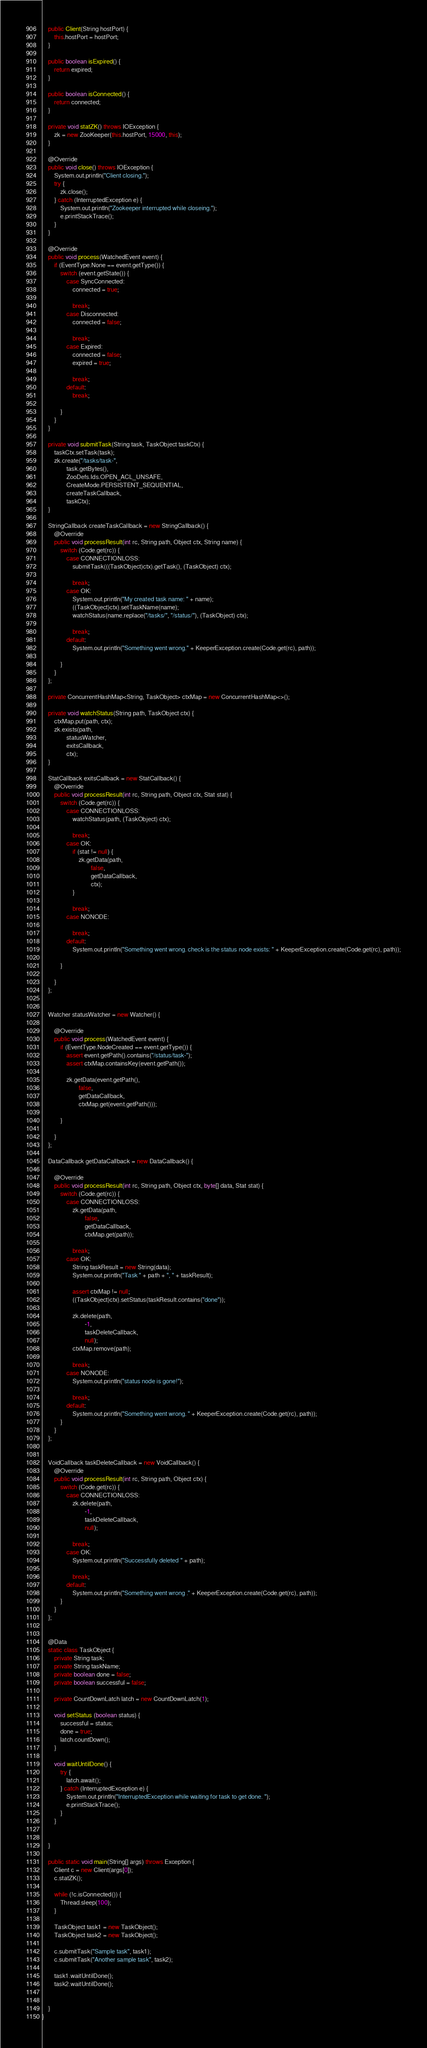Convert code to text. <code><loc_0><loc_0><loc_500><loc_500><_Java_>
	public Client(String hostPort) {
		this.hostPort = hostPort;
	}

	public boolean isExpired() {
		return expired;
	}

	public boolean isConnected() {
		return connected;
	}

	private void statZK() throws IOException {
		zk = new ZooKeeper(this.hostPort, 15000, this);
	}

	@Override
	public void close() throws IOException {
		System.out.println("Client closing.");
		try {
			zk.close();
		} catch (InterruptedException e) {
			System.out.println("Zookeeper interrupted while closeing.");
			e.printStackTrace();
		}
	}

	@Override
	public void process(WatchedEvent event) {
		if (EventType.None == event.getType()) {
			switch (event.getState()) {
				case SyncConnected:
					connected = true;

					break;
				case Disconnected:
					connected = false;

					break;
				case Expired:
					connected = false;
					expired = true;

					break;
				default:
					break;

			}
		}
	}

	private void submitTask(String task, TaskObject taskCtx) {
		taskCtx.setTask(task);
		zk.create("/tasks/task-",
				task.getBytes(),
				ZooDefs.Ids.OPEN_ACL_UNSAFE,
				CreateMode.PERSISTENT_SEQUENTIAL,
				createTaskCallback,
				taskCtx);
	}

	StringCallback createTaskCallback = new StringCallback() {
		@Override
		public void processResult(int rc, String path, Object ctx, String name) {
			switch (Code.get(rc)) {
				case CONNECTIONLOSS:
					submitTask(((TaskObject)ctx).getTask(), (TaskObject) ctx);

					break;
				case OK:
					System.out.println("My created task name: " + name);
					((TaskObject)ctx).setTaskName(name);
					watchStatus(name.replace("/tasks/", "/status/"), (TaskObject) ctx);

					break;
				default:
					System.out.println("Something went wrong." + KeeperException.create(Code.get(rc), path));

			}
		}
	};

	private ConcurrentHashMap<String, TaskObject> ctxMap = new ConcurrentHashMap<>();

	private void watchStatus(String path, TaskObject ctx) {
		ctxMap.put(path, ctx);
		zk.exists(path,
				statusWatcher,
				exitsCallback,
				ctx);
	}

	StatCallback exitsCallback = new StatCallback() {
		@Override
		public void processResult(int rc, String path, Object ctx, Stat stat) {
			switch (Code.get(rc)) {
				case CONNECTIONLOSS:
					watchStatus(path, (TaskObject) ctx);

					break;
				case OK:
					if (stat != null) {
						zk.getData(path,
								false,
								getDataCallback,
								ctx);
					}

					break;
				case NONODE:

					break;
				default:
					System.out.println("Something went wrong. check is the status node exists: " + KeeperException.create(Code.get(rc), path));

			}

		}
	};


	Watcher statusWatcher = new Watcher() {

		@Override
		public void process(WatchedEvent event) {
			if (EventType.NodeCreated == event.getType()) {
				assert event.getPath().contains("/status/task-");
				assert ctxMap.containsKey(event.getPath());

				zk.getData(event.getPath(),
						false,
						getDataCallback,
						ctxMap.get(event.getPath()));

			}

		}
	};

	DataCallback getDataCallback = new DataCallback() {

		@Override
		public void processResult(int rc, String path, Object ctx, byte[] data, Stat stat) {
			switch (Code.get(rc)) {
				case CONNECTIONLOSS:
					zk.getData(path,
							false,
							getDataCallback,
							ctxMap.get(path));

					break;
				case OK:
					String taskResult = new String(data);
					System.out.println("Task " + path + ", " + taskResult);

					assert ctxMap != null;
					((TaskObject)ctx).setStatus(taskResult.contains("done"));

					zk.delete(path,
							-1,
							taskDeleteCallback,
							null);
					ctxMap.remove(path);

					break;
				case NONODE:
					System.out.println("status node is gone!");

					break;
				default:
					System.out.println("Something went wrong. " + KeeperException.create(Code.get(rc), path));
			}
		}
	};


	VoidCallback taskDeleteCallback = new VoidCallback() {
		@Override
		public void processResult(int rc, String path, Object ctx) {
			switch (Code.get(rc)) {
				case CONNECTIONLOSS:
					zk.delete(path,
							-1,
							taskDeleteCallback,
							null);

					break;
				case OK:
					System.out.println("Successfully deleted " + path);

					break;
				default:
					System.out.println("Something went wrong ." + KeeperException.create(Code.get(rc), path));
			}
		}
	};


	@Data
	static class TaskObject {
		private String task;
		private String taskName;
		private boolean done = false;
		private boolean successful = false;

		private CountDownLatch latch = new CountDownLatch(1);

		void setStatus (boolean status) {
			successful = status;
			done = true;
			latch.countDown();
		}

		void waitUntilDone() {
			try {
				latch.await();
			} catch (InterruptedException e) {
				System.out.println("InterruptedException while waiting for task to get done. ");
				e.printStackTrace();
			}
		}


	}

	public static void main(String[] args) throws Exception {
		Client c = new Client(args[0]);
		c.statZK();

		while (!c.isConnected()) {
			Thread.sleep(100);
		}

		TaskObject task1 = new TaskObject();
		TaskObject task2 = new TaskObject();

		c.submitTask("Sample task", task1);
		c.submitTask("Another sample task", task2);

		task1.waitUntilDone();
		task2.waitUntilDone();


	}
}
</code> 